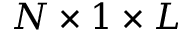Convert formula to latex. <formula><loc_0><loc_0><loc_500><loc_500>N \times 1 \times L</formula> 